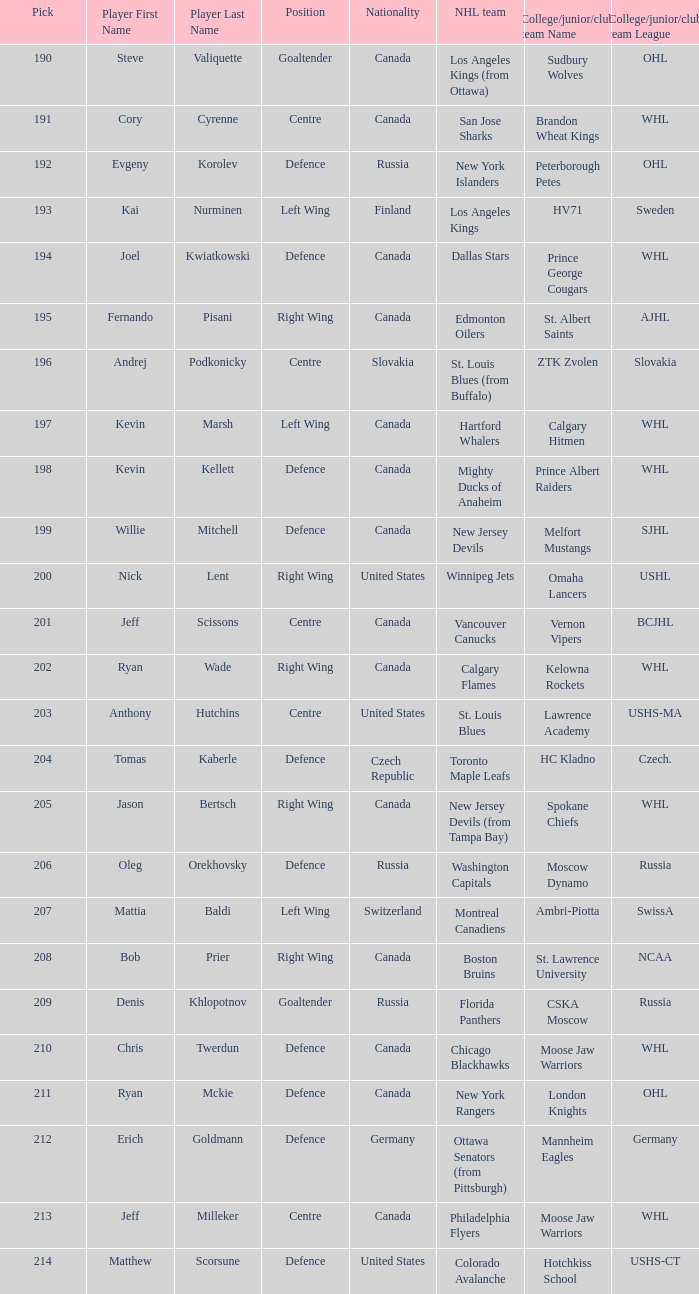Name the most pick for evgeny korolev 192.0. Could you parse the entire table? {'header': ['Pick', 'Player First Name', 'Player Last Name', 'Position', 'Nationality', 'NHL team', 'College/junior/club team Name', 'College/junior/club team League'], 'rows': [['190', 'Steve', 'Valiquette', 'Goaltender', 'Canada', 'Los Angeles Kings (from Ottawa)', 'Sudbury Wolves', 'OHL'], ['191', 'Cory', 'Cyrenne', 'Centre', 'Canada', 'San Jose Sharks', 'Brandon Wheat Kings', 'WHL'], ['192', 'Evgeny', 'Korolev', 'Defence', 'Russia', 'New York Islanders', 'Peterborough Petes', 'OHL'], ['193', 'Kai', 'Nurminen', 'Left Wing', 'Finland', 'Los Angeles Kings', 'HV71', 'Sweden'], ['194', 'Joel', 'Kwiatkowski', 'Defence', 'Canada', 'Dallas Stars', 'Prince George Cougars', 'WHL'], ['195', 'Fernando', 'Pisani', 'Right Wing', 'Canada', 'Edmonton Oilers', 'St. Albert Saints', 'AJHL'], ['196', 'Andrej', 'Podkonicky', 'Centre', 'Slovakia', 'St. Louis Blues (from Buffalo)', 'ZTK Zvolen', 'Slovakia'], ['197', 'Kevin', 'Marsh', 'Left Wing', 'Canada', 'Hartford Whalers', 'Calgary Hitmen', 'WHL'], ['198', 'Kevin', 'Kellett', 'Defence', 'Canada', 'Mighty Ducks of Anaheim', 'Prince Albert Raiders', 'WHL'], ['199', 'Willie', 'Mitchell', 'Defence', 'Canada', 'New Jersey Devils', 'Melfort Mustangs', 'SJHL'], ['200', 'Nick', 'Lent', 'Right Wing', 'United States', 'Winnipeg Jets', 'Omaha Lancers', 'USHL'], ['201', 'Jeff', 'Scissons', 'Centre', 'Canada', 'Vancouver Canucks', 'Vernon Vipers', 'BCJHL'], ['202', 'Ryan', 'Wade', 'Right Wing', 'Canada', 'Calgary Flames', 'Kelowna Rockets', 'WHL'], ['203', 'Anthony', 'Hutchins', 'Centre', 'United States', 'St. Louis Blues', 'Lawrence Academy', 'USHS-MA'], ['204', 'Tomas', 'Kaberle', 'Defence', 'Czech Republic', 'Toronto Maple Leafs', 'HC Kladno', 'Czech.'], ['205', 'Jason', 'Bertsch', 'Right Wing', 'Canada', 'New Jersey Devils (from Tampa Bay)', 'Spokane Chiefs', 'WHL'], ['206', 'Oleg', 'Orekhovsky', 'Defence', 'Russia', 'Washington Capitals', 'Moscow Dynamo', 'Russia'], ['207', 'Mattia', 'Baldi', 'Left Wing', 'Switzerland', 'Montreal Canadiens', 'Ambri-Piotta', 'SwissA'], ['208', 'Bob', 'Prier', 'Right Wing', 'Canada', 'Boston Bruins', 'St. Lawrence University', 'NCAA'], ['209', 'Denis', 'Khlopotnov', 'Goaltender', 'Russia', 'Florida Panthers', 'CSKA Moscow', 'Russia'], ['210', 'Chris', 'Twerdun', 'Defence', 'Canada', 'Chicago Blackhawks', 'Moose Jaw Warriors', 'WHL'], ['211', 'Ryan', 'Mckie', 'Defence', 'Canada', 'New York Rangers', 'London Knights', 'OHL'], ['212', 'Erich', 'Goldmann', 'Defence', 'Germany', 'Ottawa Senators (from Pittsburgh)', 'Mannheim Eagles', 'Germany'], ['213', 'Jeff', 'Milleker', 'Centre', 'Canada', 'Philadelphia Flyers', 'Moose Jaw Warriors', 'WHL'], ['214', 'Matthew', 'Scorsune', 'Defence', 'United States', 'Colorado Avalanche', 'Hotchkiss School', 'USHS-CT']]} 